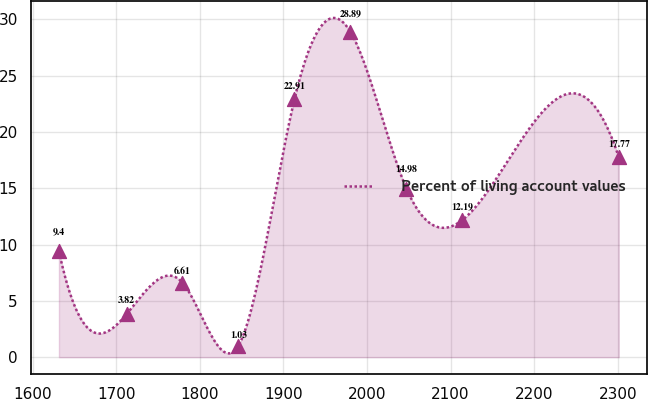<chart> <loc_0><loc_0><loc_500><loc_500><line_chart><ecel><fcel>Percent of living account values<nl><fcel>1631.47<fcel>9.4<nl><fcel>1712.31<fcel>3.82<nl><fcel>1779.29<fcel>6.61<nl><fcel>1846.27<fcel>1.03<nl><fcel>1913.25<fcel>22.91<nl><fcel>1980.23<fcel>28.89<nl><fcel>2047.21<fcel>14.98<nl><fcel>2114.19<fcel>12.19<nl><fcel>2301.29<fcel>17.77<nl></chart> 